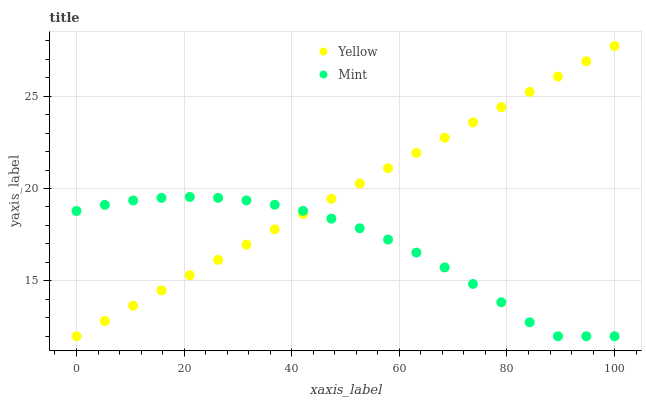Does Mint have the minimum area under the curve?
Answer yes or no. Yes. Does Yellow have the maximum area under the curve?
Answer yes or no. Yes. Does Yellow have the minimum area under the curve?
Answer yes or no. No. Is Yellow the smoothest?
Answer yes or no. Yes. Is Mint the roughest?
Answer yes or no. Yes. Is Yellow the roughest?
Answer yes or no. No. Does Mint have the lowest value?
Answer yes or no. Yes. Does Yellow have the highest value?
Answer yes or no. Yes. Does Mint intersect Yellow?
Answer yes or no. Yes. Is Mint less than Yellow?
Answer yes or no. No. Is Mint greater than Yellow?
Answer yes or no. No. 